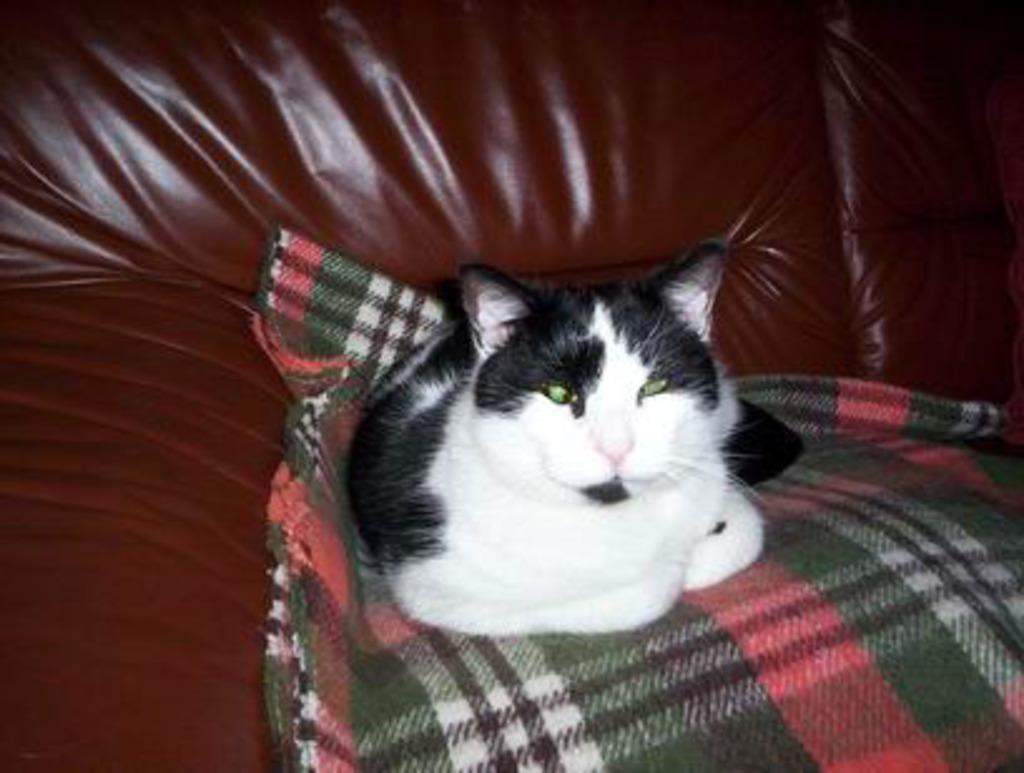What type of furniture is present in the image? There is a brown color sofa in the image. Is there any additional covering on the sofa? Yes, there is a green color cloth on the sofa. What type of animal can be seen on the sofa? There is a black and white color cat sitting on the cloth. What type of letters can be seen floating in the sky above the sofa? There are no letters floating in the sky above the sofa in the image. 